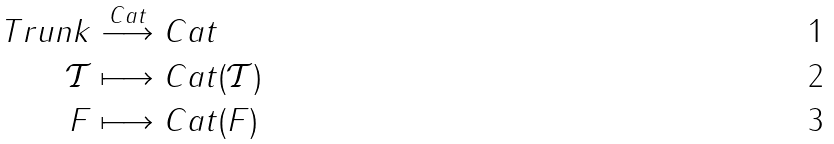Convert formula to latex. <formula><loc_0><loc_0><loc_500><loc_500>T r u n k & \stackrel { C a t } { \longrightarrow } C a t \\ \mathcal { T } & \longmapsto C a t ( \mathcal { T } ) \\ F & \longmapsto C a t ( F )</formula> 